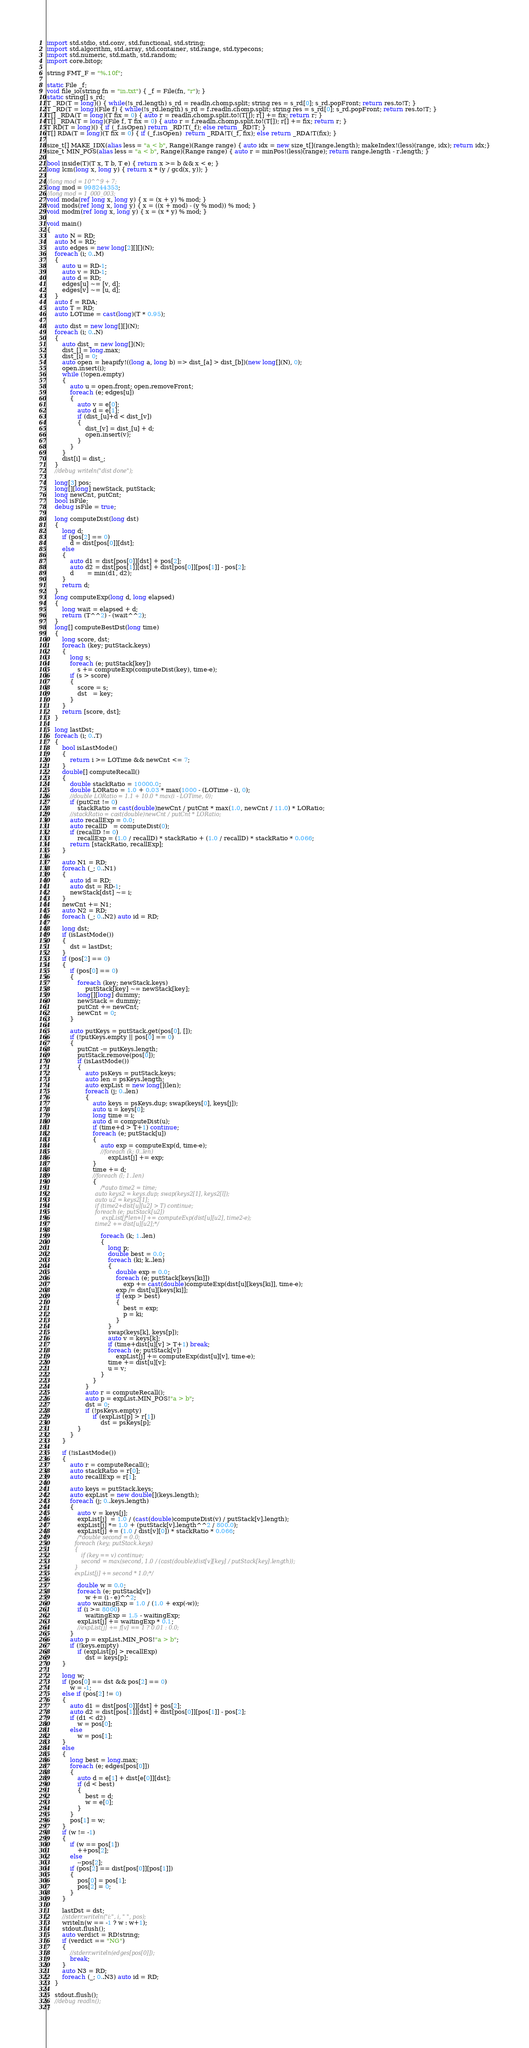<code> <loc_0><loc_0><loc_500><loc_500><_D_>import std.stdio, std.conv, std.functional, std.string;
import std.algorithm, std.array, std.container, std.range, std.typecons;
import std.numeric, std.math, std.random;
import core.bitop;

string FMT_F = "%.10f";

static File _f;
void file_io(string fn = "in.txt") { _f = File(fn, "r"); }
static string[] s_rd;
T _RD(T = long)() { while(!s_rd.length) s_rd = readln.chomp.split; string res = s_rd[0]; s_rd.popFront; return res.to!T; }
T _RD(T = long)(File f) { while(!s_rd.length) s_rd = f.readln.chomp.split; string res = s_rd[0]; s_rd.popFront; return res.to!T; }
T[] _RDA(T = long)(T fix = 0) { auto r = readln.chomp.split.to!(T[]); r[] += fix; return r; }
T[] _RDA(T = long)(File f, T fix = 0) { auto r = f.readln.chomp.split.to!(T[]); r[] += fix; return r; }
T RD(T = long)() { if (_f.isOpen) return _RD!T(_f); else return _RD!T; }
T[] RDA(T = long)(T fix = 0) { if (_f.isOpen)  return _RDA!T(_f, fix); else return _RDA!T(fix); }

size_t[] MAKE_IDX(alias less = "a < b", Range)(Range range) { auto idx = new size_t[](range.length); makeIndex!(less)(range, idx); return idx;}
size_t MIN_POS(alias less = "a < b", Range)(Range range) { auto r = minPos!(less)(range); return range.length - r.length; }

bool inside(T)(T x, T b, T e) { return x >= b && x < e; }
long lcm(long x, long y) { return x * (y / gcd(x, y)); }

//long mod = 10^^9 + 7;
long mod = 998244353;
//long mod = 1_000_003;
void moda(ref long x, long y) { x = (x + y) % mod; }
void mods(ref long x, long y) { x = ((x + mod) - (y % mod)) % mod; }
void modm(ref long x, long y) { x = (x * y) % mod; }

void main()
{
	auto N = RD;
	auto M = RD;
	auto edges = new long[2][][](N);
	foreach (i; 0..M)
	{
		auto u = RD-1;
		auto v = RD-1;
		auto d = RD;
		edges[u] ~= [v, d];
		edges[v] ~= [u, d];
	}
	auto f = RDA;
	auto T = RD;
	auto LOTime = cast(long)(T * 0.95);

	auto dist = new long[][](N);
	foreach (i; 0..N)
	{
		auto dist_ = new long[](N);
		dist_[] = long.max;
		dist_[i] = 0;
		auto open = heapify!((long a, long b) => dist_[a] > dist_[b])(new long[](N), 0);
		open.insert(i);
		while (!open.empty)
		{
			auto u = open.front; open.removeFront;
			foreach (e; edges[u])
			{
				auto v = e[0];
				auto d = e[1];
				if (dist_[u]+d < dist_[v])
				{
					dist_[v] = dist_[u] + d;
					open.insert(v);
				}
			}
		}
		dist[i] = dist_;
	}
	//debug writeln("dist done");

	long[3] pos;
	long[][long] newStack, putStack;
	long newCnt, putCnt;
	bool isFile;
	debug isFile = true;

	long computeDist(long dst)
	{
		long d;
		if (pos[2] == 0)
			d = dist[pos[0]][dst];
		else
		{
			auto d1 = dist[pos[0]][dst] + pos[2];
			auto d2 = dist[pos[1]][dst] + dist[pos[0]][pos[1]] - pos[2];
			d       = min(d1, d2);
		}
		return d;
	}
	long computeExp(long d, long elapsed)
	{
		long wait = elapsed + d;
		return (T^^2) - (wait^^2);
	}
	long[] computeBestDst(long time)
	{
		long score, dst;
		foreach (key; putStack.keys)
		{
			long s;
			foreach (e; putStack[key])
				s += computeExp(computeDist(key), time-e);
			if (s > score)
			{
				score = s;
				dst   = key;
			}
		}
		return [score, dst];
	}
	
	long lastDst;
	foreach (i; 0..T)
	{
		bool isLastMode()
		{
			return i >= LOTime && newCnt <= 7;
		}
		double[] computeRecall()
		{
			double stackRatio = 10000.0;
			double LORatio = 1.0 + 0.03 * max(1000 - (LOTime - i), 0);
			//double LORatio = 1.1 + 10.0 * max(i - LOTime, 0);
			if (putCnt != 0)
				stackRatio = cast(double)newCnt / putCnt * max(1.0, newCnt / 11.0) * LORatio;
			//stackRatio = cast(double)newCnt / putCnt * LORatio;
			auto recallExp = 0.0;
			auto recallD   = computeDist(0);
			if (recallD != 0)
				recallExp = (1.0 / recallD) * stackRatio + (1.0 / recallD) * stackRatio * 0.066;
			return [stackRatio, recallExp];
		}

		auto N1 = RD;
		foreach (_; 0..N1)
		{
			auto id = RD;
			auto dst = RD-1;
			newStack[dst] ~= i;
		}
		newCnt += N1;
		auto N2 = RD;
		foreach (_; 0..N2) auto id = RD;

		long dst;
		if (isLastMode())
		{
			dst = lastDst;
		}
		if (pos[2] == 0)
		{
			if (pos[0] == 0)
			{
				foreach (key; newStack.keys)
					putStack[key] ~= newStack[key];
				long[][long] dummy;
				newStack = dummy;
				putCnt += newCnt;
				newCnt = 0;
			}

			auto putKeys = putStack.get(pos[0], []);
			if (!putKeys.empty || pos[0] == 0)
			{
				putCnt -= putKeys.length;
				putStack.remove(pos[0]);
				if (isLastMode())
				{
					auto psKeys = putStack.keys;
					auto len = psKeys.length;
					auto expList = new long[](len);
					foreach (j; 0..len)
					{
						auto keys = psKeys.dup; swap(keys[0], keys[j]);
						auto u = keys[0];
						long time = i;
						auto d = computeDist(u);
						if (time+d > T+1) continue;
						foreach (e; putStack[u])
						{
							auto exp = computeExp(d, time-e);
							//foreach (k; 0..len)
								expList[j] += exp;
						}
						time += d;
						//foreach (l; 1..len)
						{
							/*auto time2 = time;
							auto keys2 = keys.dup; swap(keys2[1], keys2[l]);
							auto u2 = keys2[1];
							if (time2+dist[u][u2] > T) continue;
							foreach (e; putStack[u2])
								expList[j*len+l] += computeExp(dist[u][u2], time2-e);
							time2 += dist[u][u2];*/

							foreach (k; 1..len)
							{
								long p;
								double best = 0.0;
								foreach (ki; k..len)
								{
									double exp = 0.0;
									foreach (e; putStack[keys[ki]])
										exp += cast(double)computeExp(dist[u][keys[ki]], time-e);
									exp /= dist[u][keys[ki]];
									if (exp > best)
									{
										best = exp;
										p = ki;
									}
								}
								swap(keys[k], keys[p]);
								auto v = keys[k];
								if (time+dist[u][v] > T+1) break;
								foreach (e; putStack[v])
									expList[j] += computeExp(dist[u][v], time-e);
								time += dist[u][v];
								u = v;
							}
						}
					}
					auto r = computeRecall();
					auto p = expList.MIN_POS!"a > b";
					dst = 0;
					if (!psKeys.empty)
						if (expList[p] > r[1])
							dst = psKeys[p];
				}
			}
		}

		if (!isLastMode())
		{
			auto r = computeRecall();
			auto stackRatio = r[0];
			auto recallExp = r[1];

			auto keys = putStack.keys;
			auto expList = new double[](keys.length);
			foreach (j; 0..keys.length)
			{
				auto v = keys[j];
				expList[j]  = 1.0 / (cast(double)computeDist(v) / putStack[v].length);
				expList[j] *= 1.0 + (putStack[v].length^^2 / 800.0);
				expList[j] += (1.0 / dist[v][0]) * stackRatio * 0.066;
				/*double second = 0.0;
				foreach (key; putStack.keys)
				{
					if (key == v) continue;
					second = max(second, 1.0 / (cast(double)dist[v][key] / putStack[key].length));
				}
				expList[j] += second * 1.0;*/

				double w = 0.0;
				foreach (e; putStack[v])
					w += (i - e)^^2;
				auto waitingExp = 1.0 / (1.0 + exp(-w));
				if (i >= 8000)
					waitingExp = 1.5 - waitingExp;
				expList[j] += waitingExp * 0.1;
				//expList[j] += f[v] == 1 ? 0.01 : 0.0;
			}
			auto p = expList.MIN_POS!"a > b";
			if (!keys.empty)
				if (expList[p] > recallExp)
					dst = keys[p];
		}

		long w;
		if (pos[0] == dst && pos[2] == 0)
			w = -1;
		else if (pos[2] != 0)
		{
			auto d1 = dist[pos[0]][dst] + pos[2];
			auto d2 = dist[pos[1]][dst] + dist[pos[0]][pos[1]] - pos[2];
			if (d1 < d2)
				w = pos[0];
			else
				w = pos[1];
		}
		else
		{
			long best = long.max;
			foreach (e; edges[pos[0]])
			{
				auto d = e[1] + dist[e[0]][dst];
				if (d < best)
				{
					best = d;
					w = e[0];
				}
			}
			pos[1] = w;
		}
		if (w != -1)
		{
			if (w == pos[1])
				++pos[2];
			else
				--pos[2];
			if (pos[2] == dist[pos[0]][pos[1]])
			{
				pos[0] = pos[1];
				pos[2] = 0;
			}
		}

		lastDst = dst;
		//stderr.writeln("i:", i, " ", pos);
		writeln(w == -1 ? w : w+1);
		stdout.flush();
		auto verdict = RD!string;
		if (verdict == "NG")
		{
			//stderr.writeln(edges[pos[0]]);
			break;
		}
		auto N3 = RD;
		foreach (_; 0..N3) auto id = RD;
	}

	stdout.flush();
	//debug readln();
}</code> 